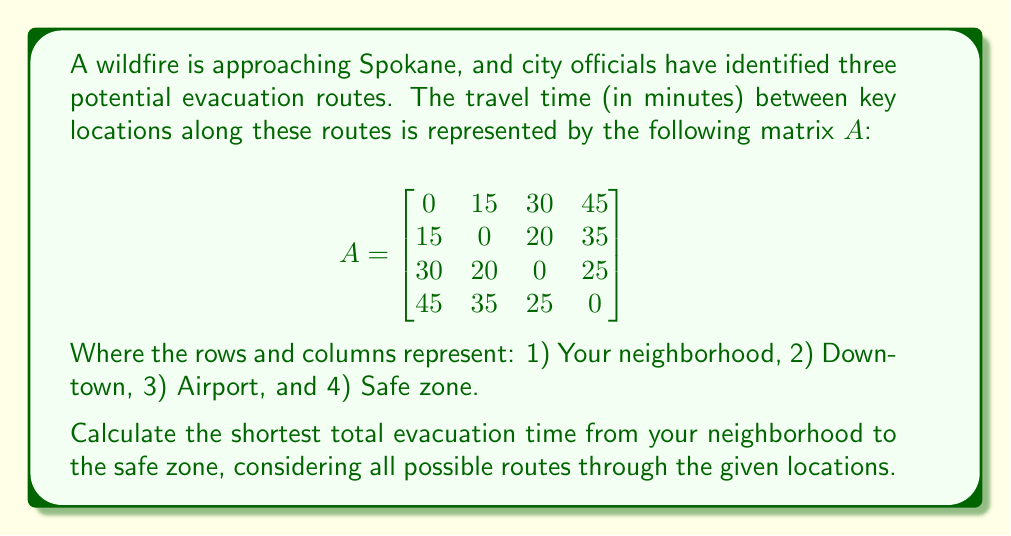Solve this math problem. To solve this problem, we'll use the Floyd-Warshall algorithm, which can be implemented using matrix operations:

1) First, we'll create a series of matrices $A^{(k)}$, where $k$ goes from 0 to 4 (the number of locations).

2) $A^{(0)}$ is our initial matrix $A$.

3) For each $k$ from 1 to 4, we'll calculate $A^{(k)}$ using the formula:

   $a_{ij}^{(k)} = \min(a_{ij}^{(k-1)}, a_{ik}^{(k-1)} + a_{kj}^{(k-1)})$

4) Let's calculate each matrix:

   $A^{(1)} = A^{(0)} = A$ (no changes, as going through the neighborhood doesn't create shorter paths)

   $A^{(2)}$:
   $$A^{(2)} = \begin{bmatrix}
   0 & 15 & 30 & 45 \\
   15 & 0 & 20 & 35 \\
   30 & 20 & 0 & 25 \\
   45 & 35 & 25 & 0
   \end{bmatrix}$$

   $A^{(3)}$:
   $$A^{(3)} = \begin{bmatrix}
   0 & 15 & 30 & 45 \\
   15 & 0 & 20 & 35 \\
   30 & 20 & 0 & 25 \\
   45 & 35 & 25 & 0
   \end{bmatrix}$$

   $A^{(4)}$:
   $$A^{(4)} = \begin{bmatrix}
   0 & 15 & 30 & 45 \\
   15 & 0 & 20 & 35 \\
   30 & 20 & 0 & 25 \\
   45 & 35 & 25 & 0
   \end{bmatrix}$$

5) The shortest evacuation time from the neighborhood (1) to the safe zone (4) is given by $a_{14}^{(4)} = 45$ minutes.

This means that the direct route from the neighborhood to the safe zone is the fastest, and no intermediate stops reduce the total travel time.
Answer: 45 minutes 